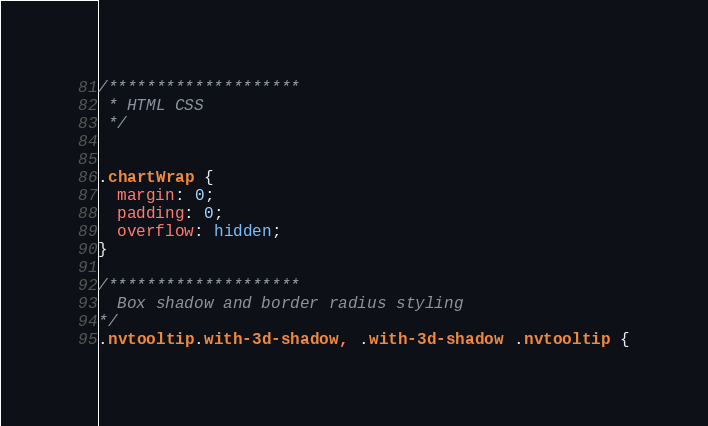<code> <loc_0><loc_0><loc_500><loc_500><_CSS_>
/********************
 * HTML CSS
 */


.chartWrap {
  margin: 0;
  padding: 0;
  overflow: hidden;
}

/********************
  Box shadow and border radius styling
*/
.nvtooltip.with-3d-shadow, .with-3d-shadow .nvtooltip {</code> 